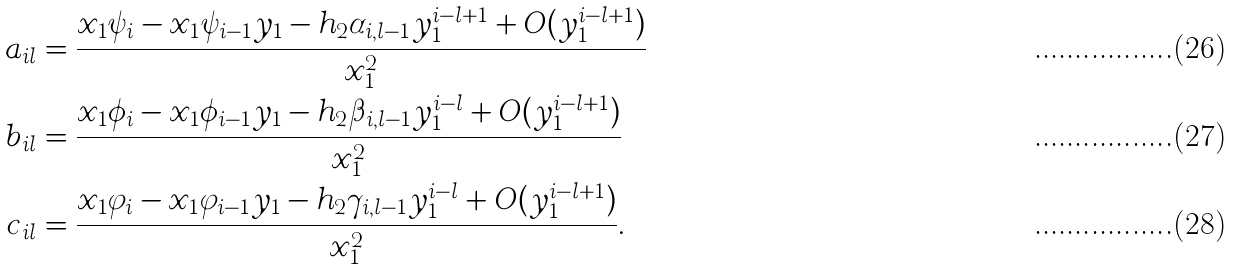Convert formula to latex. <formula><loc_0><loc_0><loc_500><loc_500>a _ { i l } & = \frac { x _ { 1 } \psi _ { i } - x _ { 1 } \psi _ { i - 1 } y _ { 1 } - h _ { 2 } \alpha _ { i , l - 1 } y _ { 1 } ^ { i - l + 1 } + O ( y _ { 1 } ^ { i - l + 1 } ) } { x _ { 1 } ^ { 2 } } \\ b _ { i l } & = \frac { x _ { 1 } \phi _ { i } - x _ { 1 } \phi _ { i - 1 } y _ { 1 } - h _ { 2 } \beta _ { i , l - 1 } y _ { 1 } ^ { i - l } + O ( y _ { 1 } ^ { i - l + 1 } ) } { x _ { 1 } ^ { 2 } } \\ c _ { i l } & = \frac { x _ { 1 } \varphi _ { i } - x _ { 1 } \varphi _ { i - 1 } y _ { 1 } - h _ { 2 } \gamma _ { i , l - 1 } y _ { 1 } ^ { i - l } + O ( y _ { 1 } ^ { i - l + 1 } ) } { x _ { 1 } ^ { 2 } } .</formula> 